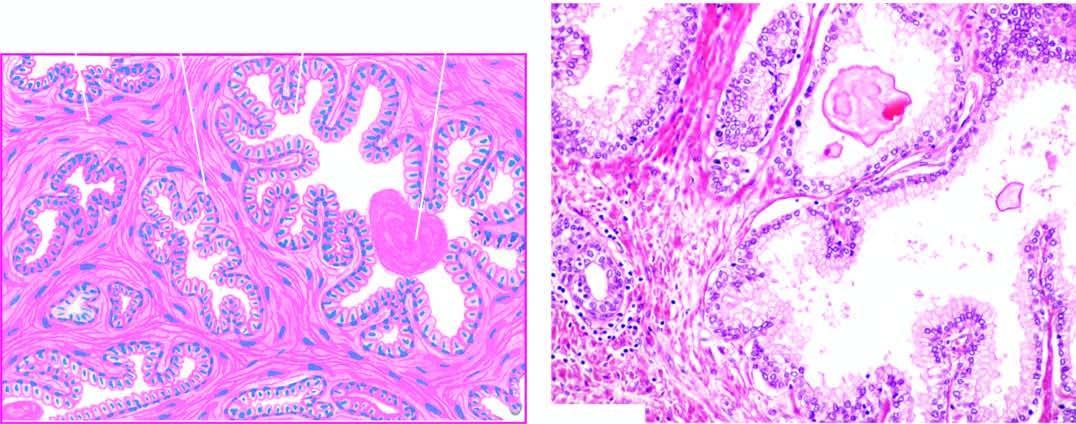what are there?
Answer the question using a single word or phrase. Areas of intra-acinar papillary infoldings lined by two layers of epithelium with basal polarity of nuclei 